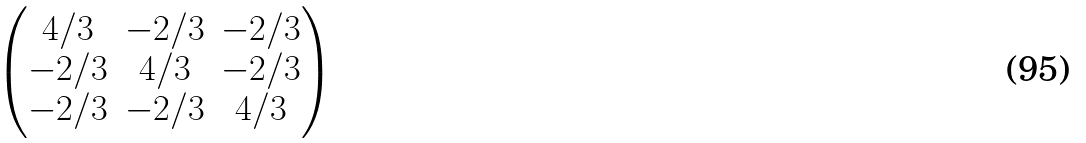<formula> <loc_0><loc_0><loc_500><loc_500>\begin{pmatrix} 4 / 3 & - 2 / 3 & - 2 / 3 \\ - 2 / 3 & 4 / 3 & - 2 / 3 \\ - 2 / 3 & - 2 / 3 & 4 / 3 \end{pmatrix}</formula> 